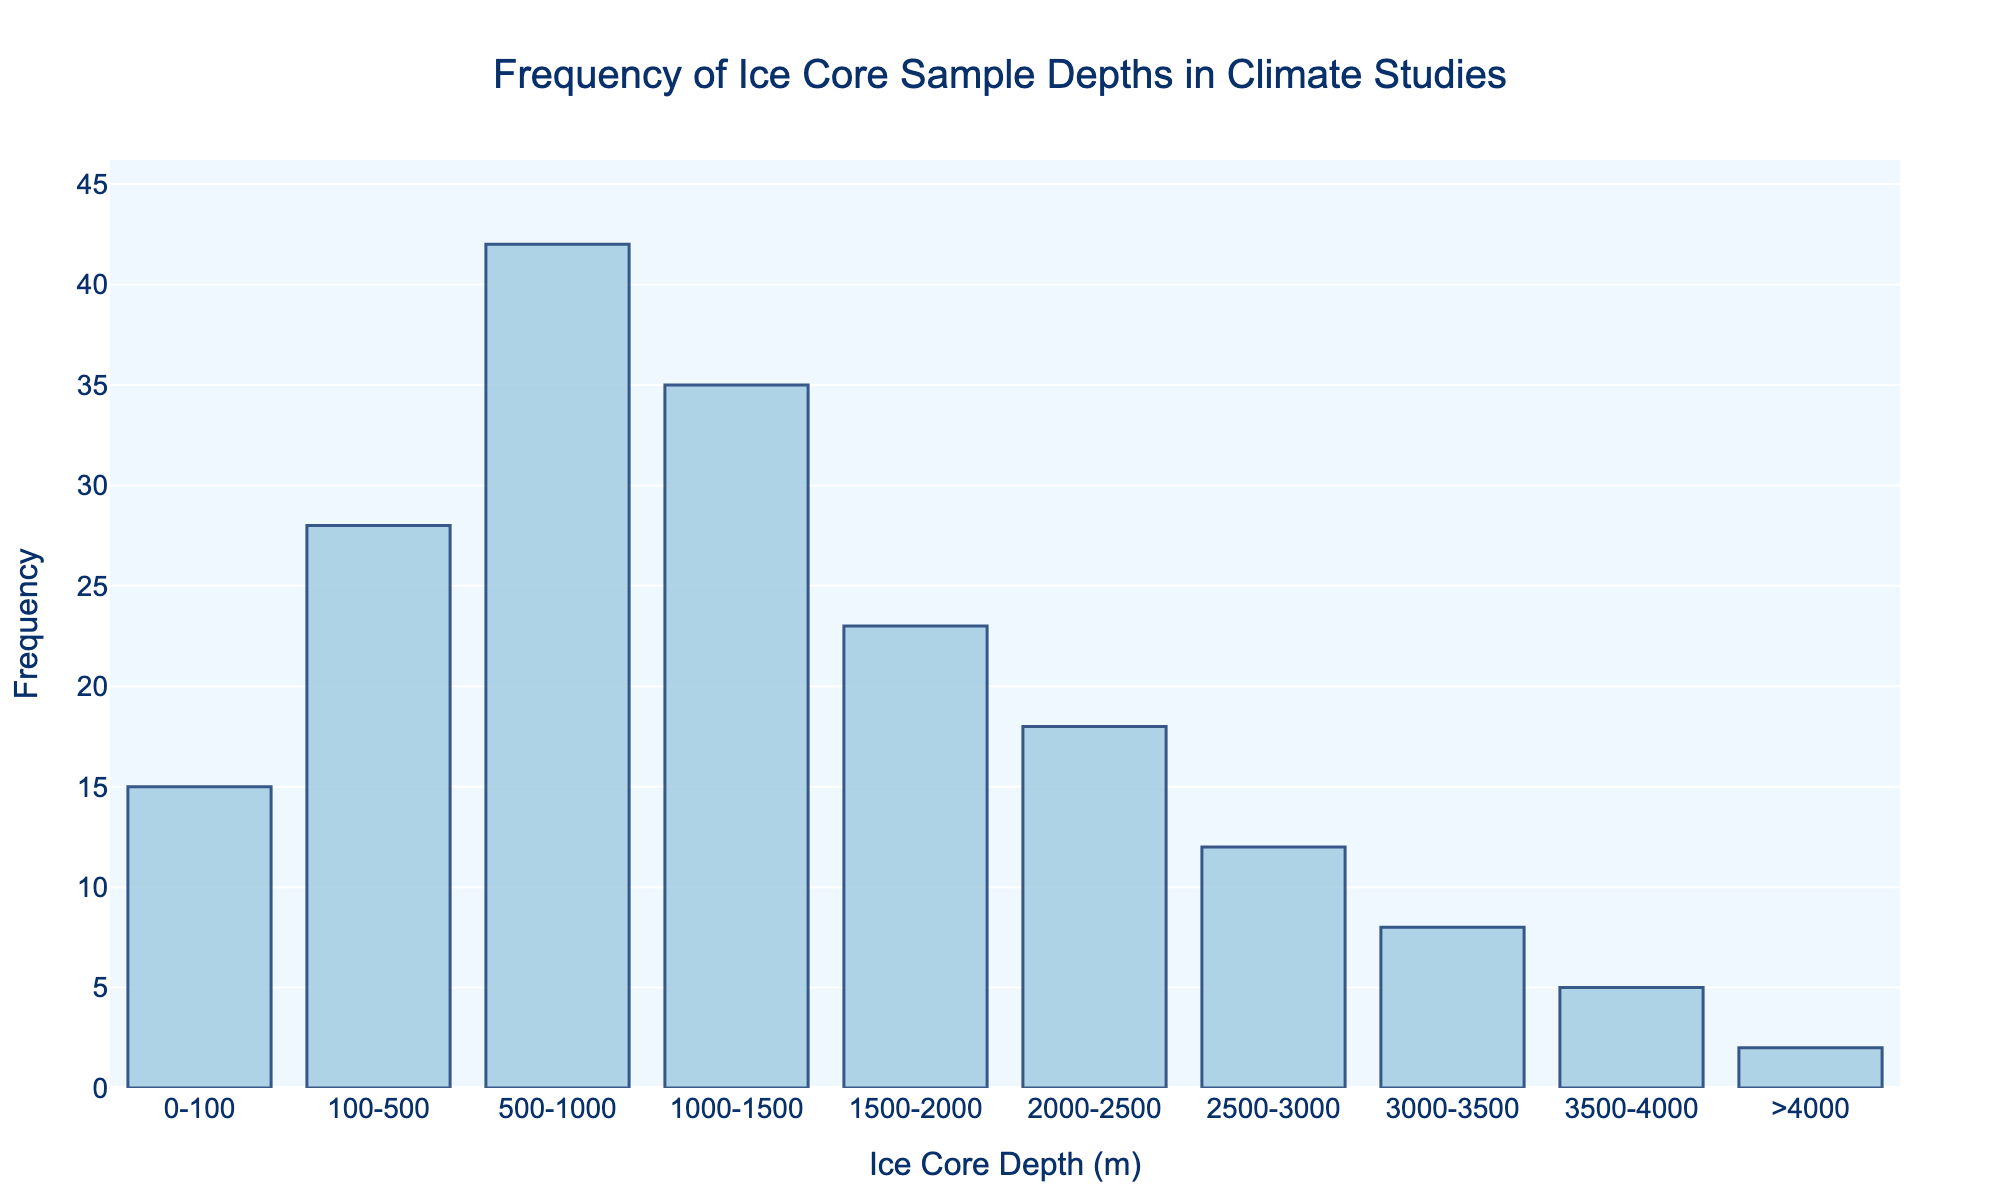What is the most frequent ice core sample depth range used in climate studies? The highest bar in the chart represents the most frequent ice core depth range. Here, the bar for the 500-1000 meter range is the tallest.
Answer: 500-1000 meters Which ice core depth range has the least frequency? The smallest bar represents the least frequent ice core depth range. The bar for the >4000 meters range is the smallest.
Answer: >4000 meters What is the average frequency of ice core samples for the ranges >2000 meters? Add the frequencies for the ranges >2000 meters and divide by the number of ranges: (18 + 12 + 8 + 5 + 2)/5. This gives (45/5).
Answer: 9 How much higher is the frequency of samples taken from 1000-1500 meters compared to 1500-2000 meters? Subtract the frequency of 1500-2000 meters from that of 1000-1500 meters (35 - 23). The difference is 12.
Answer: 12 What is the total frequency of ice core samples ranging from 0 to 1500 meters? Sum the frequencies for 0-100, 100-500, 500-1000, and 1000-1500 meters (15 + 28 + 42 + 35). This results in a total frequency of 120.
Answer: 120 Considering the visual lengths, which range's frequency is closest to 20? By looking at the heights of the bars, the bar for the 2000-2500 meter range is closest to 20 with a frequency of 18.
Answer: 2000-2500 meters If the frequency of the 100-500 meter range were doubled, how many times would it exceed the frequency of the >4000 meters range? The frequency for the 100-500 meter range is 28. If doubled, it becomes 56. Dividing this by the frequency of the >4000 meters range (2), we get 56/2, which equals 28.
Answer: 28 Which depth ranges have a frequency between 10 and 30? Identify bars with heights between the frequencies of 10 and 30. The ranges are 0-100, 100-500, 1500-2000, and 2000-2500 meters.
Answer: 0-100, 100-500, 1500-2000, 2000-2500 meters How much lesser is the frequency of the 3000-3500 meter range compared to that of the 500-1000 meter range? Subtract the frequency of the 3000-3500 meter range (8) from that of the 500-1000 meter range (42) to get (42 - 8), which is 34.
Answer: 34 